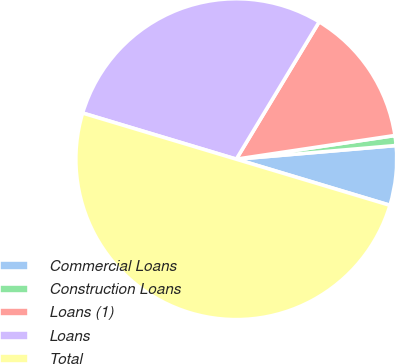Convert chart to OTSL. <chart><loc_0><loc_0><loc_500><loc_500><pie_chart><fcel>Commercial Loans<fcel>Construction Loans<fcel>Loans (1)<fcel>Loans<fcel>Total<nl><fcel>6.0%<fcel>1.0%<fcel>14.0%<fcel>29.0%<fcel>50.0%<nl></chart> 